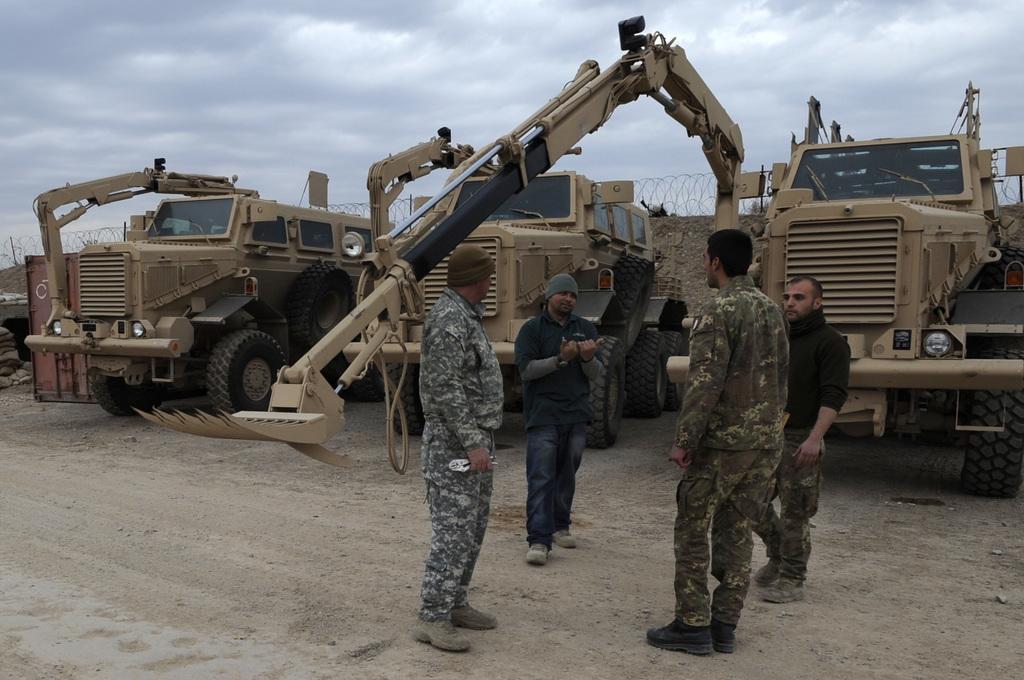Can you describe this image briefly? In this image I can see four men are standing. I can see the front two are wearing uniform and the left two are wearing caps. In the background I can see few vehicles, clouds and the sky. 